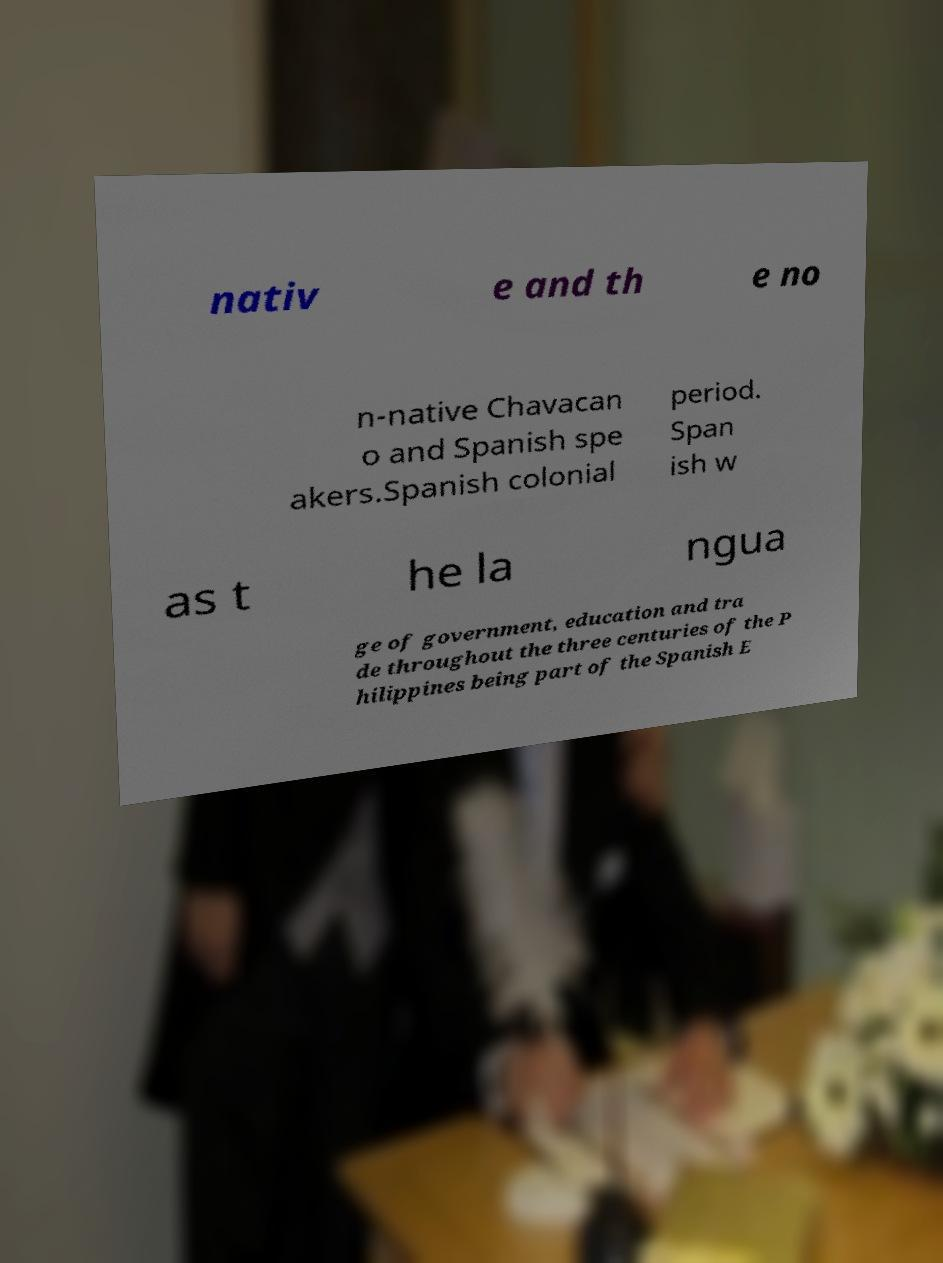What messages or text are displayed in this image? I need them in a readable, typed format. nativ e and th e no n-native Chavacan o and Spanish spe akers.Spanish colonial period. Span ish w as t he la ngua ge of government, education and tra de throughout the three centuries of the P hilippines being part of the Spanish E 